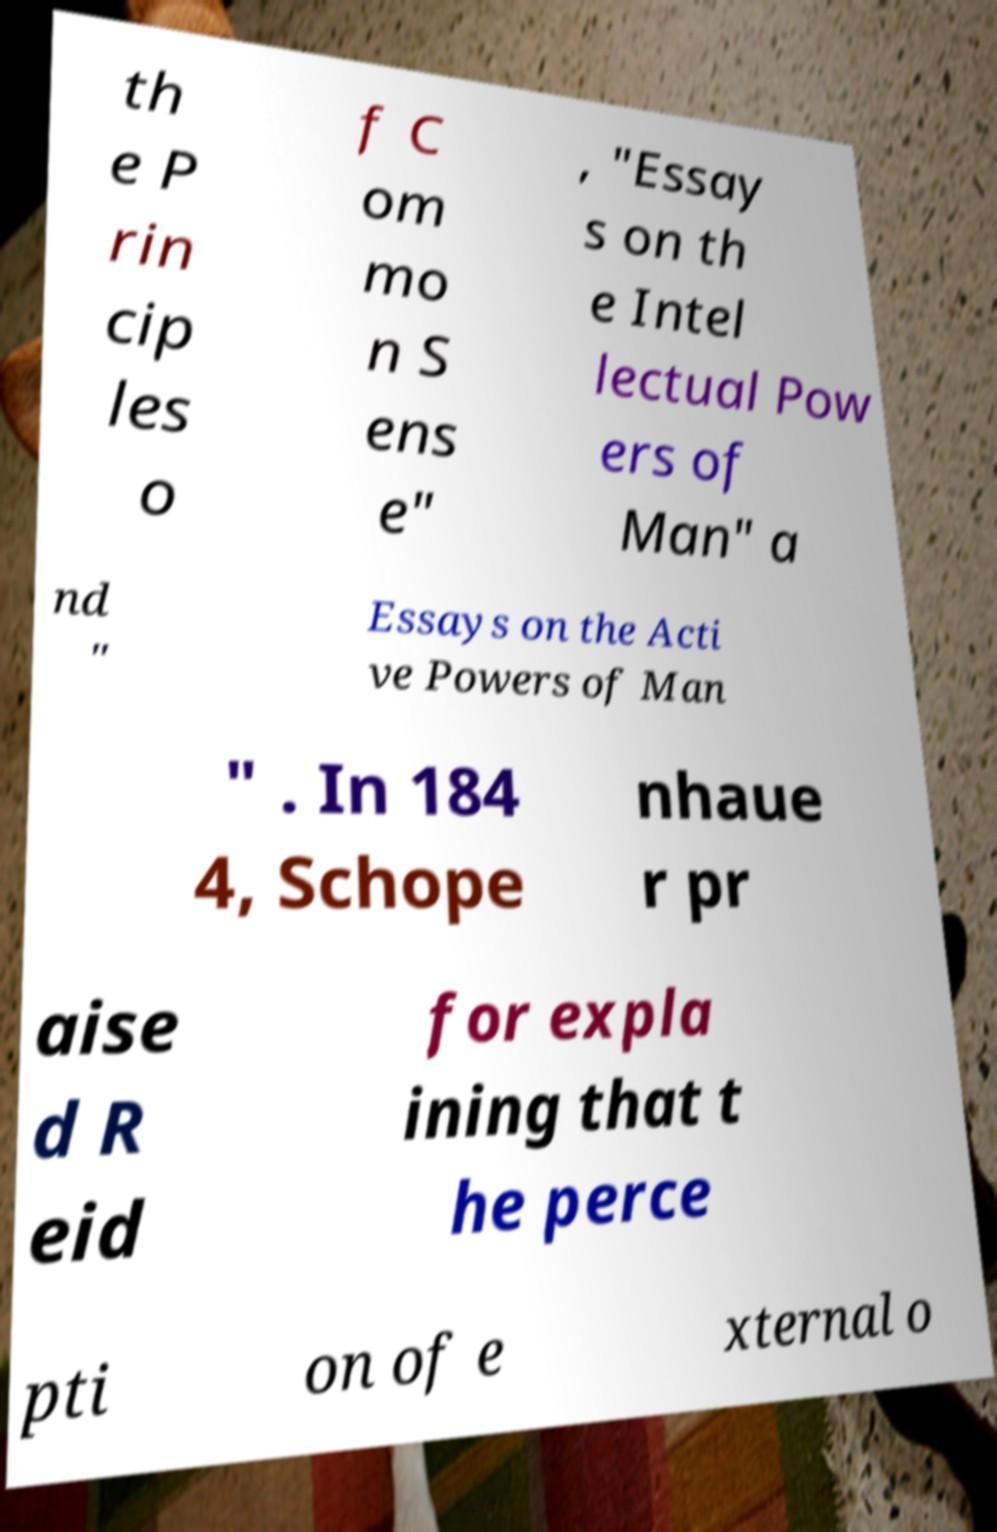Could you extract and type out the text from this image? th e P rin cip les o f C om mo n S ens e" , "Essay s on th e Intel lectual Pow ers of Man" a nd " Essays on the Acti ve Powers of Man " . In 184 4, Schope nhaue r pr aise d R eid for expla ining that t he perce pti on of e xternal o 